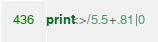Convert code to text. <code><loc_0><loc_0><loc_500><loc_500><_Perl_>print<>/5.5+.81|0</code> 